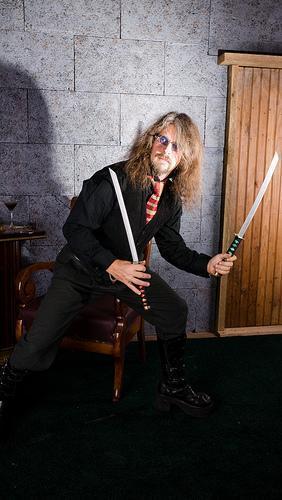How many swords does the man have?
Give a very brief answer. 2. 